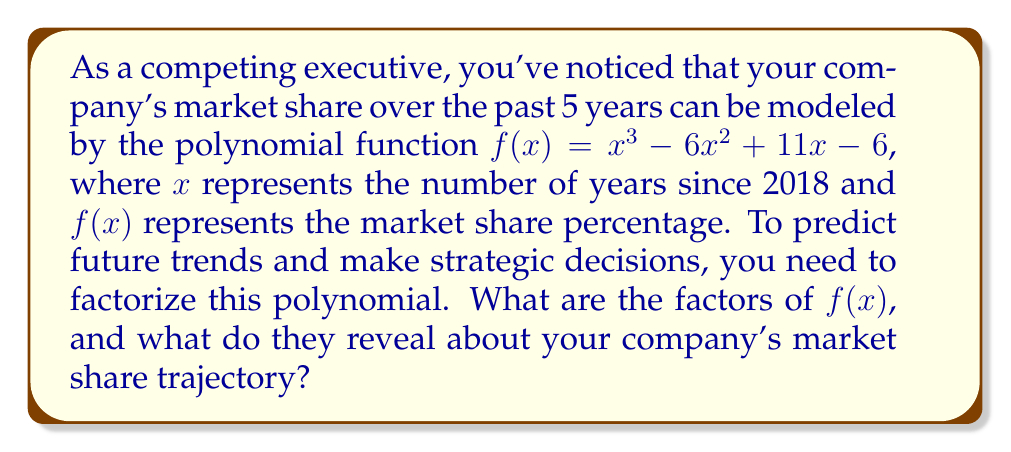Provide a solution to this math problem. Let's approach this step-by-step:

1) First, we need to factorize the polynomial $f(x) = x^3 - 6x^2 + 11x - 6$.

2) We can start by guessing one of the factors. Since the constant term is -6, possible factors are ±1, ±2, ±3, ±6. Let's try (x - 1):

   $f(1) = 1^3 - 6(1)^2 + 11(1) - 6 = 1 - 6 + 11 - 6 = 0$

   This confirms that (x - 1) is a factor.

3) We can now use polynomial long division to divide $f(x)$ by (x - 1):

   $x^3 - 6x^2 + 11x - 6 = (x - 1)(x^2 - 5x + 6)$

4) Now we need to factorize $x^2 - 5x + 6$. We can do this by finding two numbers that multiply to give 6 and add to give -5. These numbers are -2 and -3.

5) Therefore, $x^2 - 5x + 6 = (x - 2)(x - 3)$

6) Putting it all together, we get:

   $f(x) = (x - 1)(x - 2)(x - 3)$

7) Interpreting the results:
   - The roots of the polynomial are at x = 1, 2, and 3.
   - This means the market share reaches zero (or crosses the x-axis) at 1, 2, and 3 years after 2018, i.e., in 2019, 2020, and 2021.
   - The fact that the polynomial is cubic and has three real roots suggests that the market share has been fluctuating, with three points where it potentially becomes zero or changes direction.
   - The positive leading coefficient indicates that as x increases beyond the largest root (3), the market share will start to increase rapidly.

This factorization reveals a volatile market share trajectory with potential turnaround points in 2019, 2020, and 2021, followed by a projected rapid increase in market share from 2022 onwards.
Answer: $f(x) = (x - 1)(x - 2)(x - 3)$ 